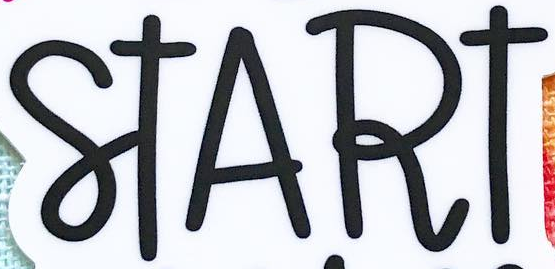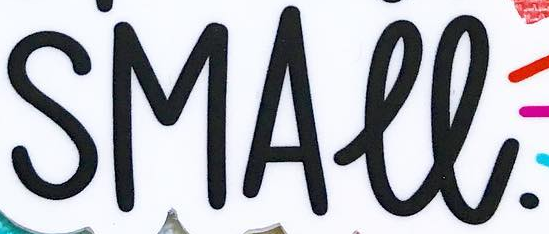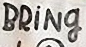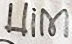What words can you see in these images in sequence, separated by a semicolon? START; SMALL.; BRİNg; Him 